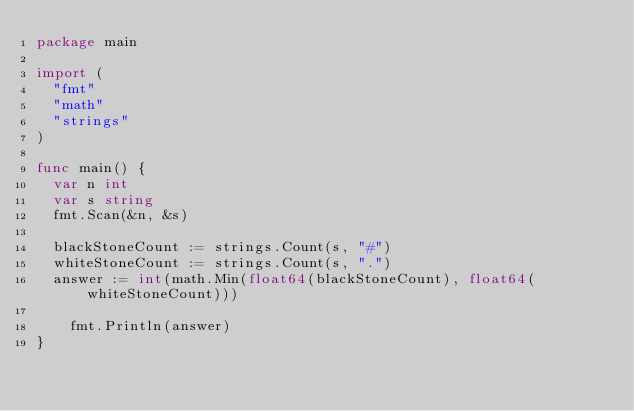Convert code to text. <code><loc_0><loc_0><loc_500><loc_500><_Go_>package main

import (
	"fmt"
	"math"
	"strings"
)

func main() {
	var n int
	var s string
	fmt.Scan(&n, &s)

	blackStoneCount := strings.Count(s, "#")
	whiteStoneCount := strings.Count(s, ".")
	answer := int(math.Min(float64(blackStoneCount), float64(whiteStoneCount)))
	
  	fmt.Println(answer)
}
</code> 